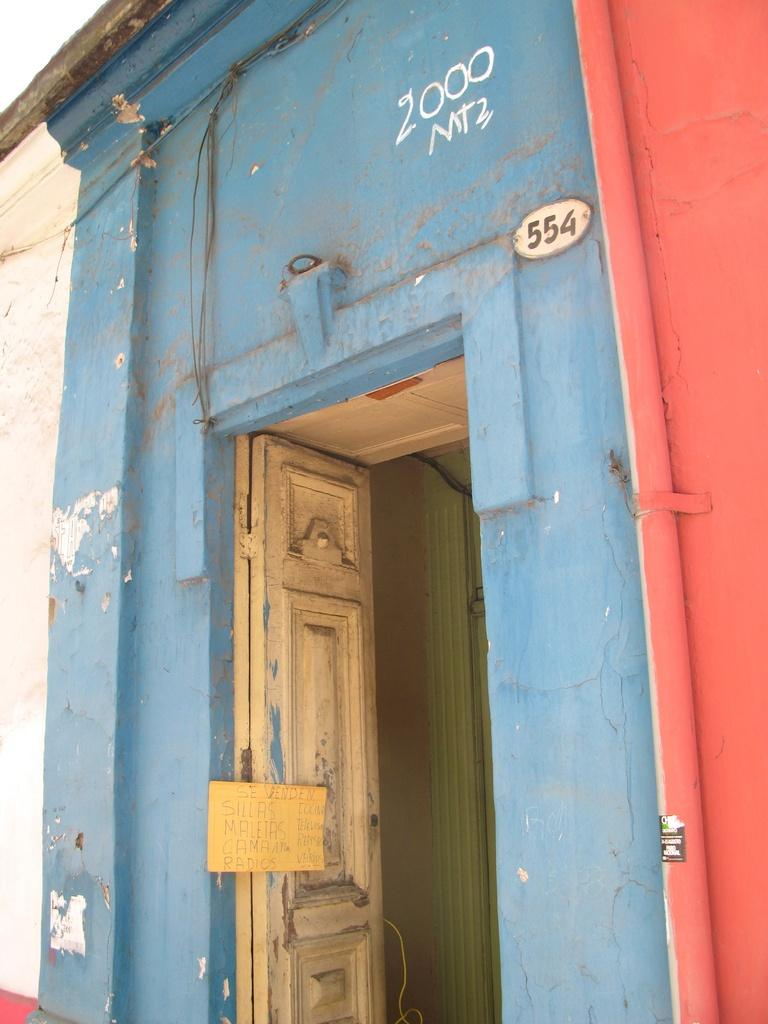What is a prominent feature in the image? There is a door in the image. What can be seen on the wall in the image? There is text written on the wall in the image. What type of net is used for playing basketball in the image? There is no net or basketball present in the image; it only features a door and text on the wall. What is the reason for the text on the wall in the image? The reason for the text on the wall cannot be determined from the image alone, as it requires additional context or information. 